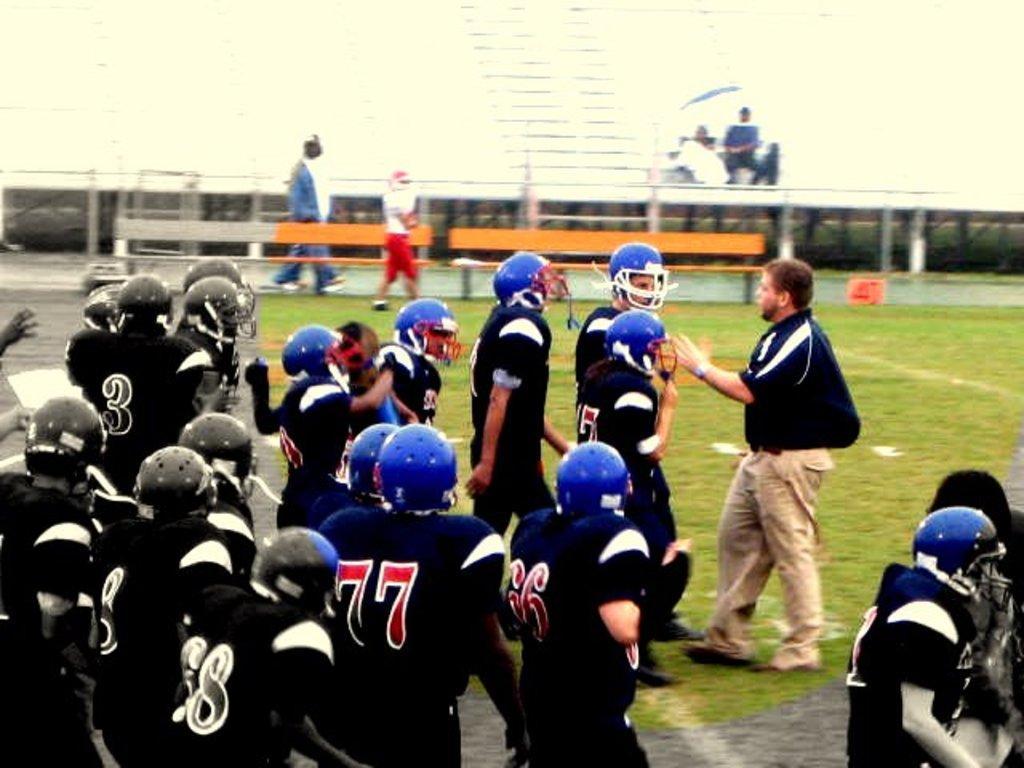Can you describe this image briefly? This is an edited image. There are people standing in the center of the image. In the background of the image there are benches. At the bottom of the image there is grass. 